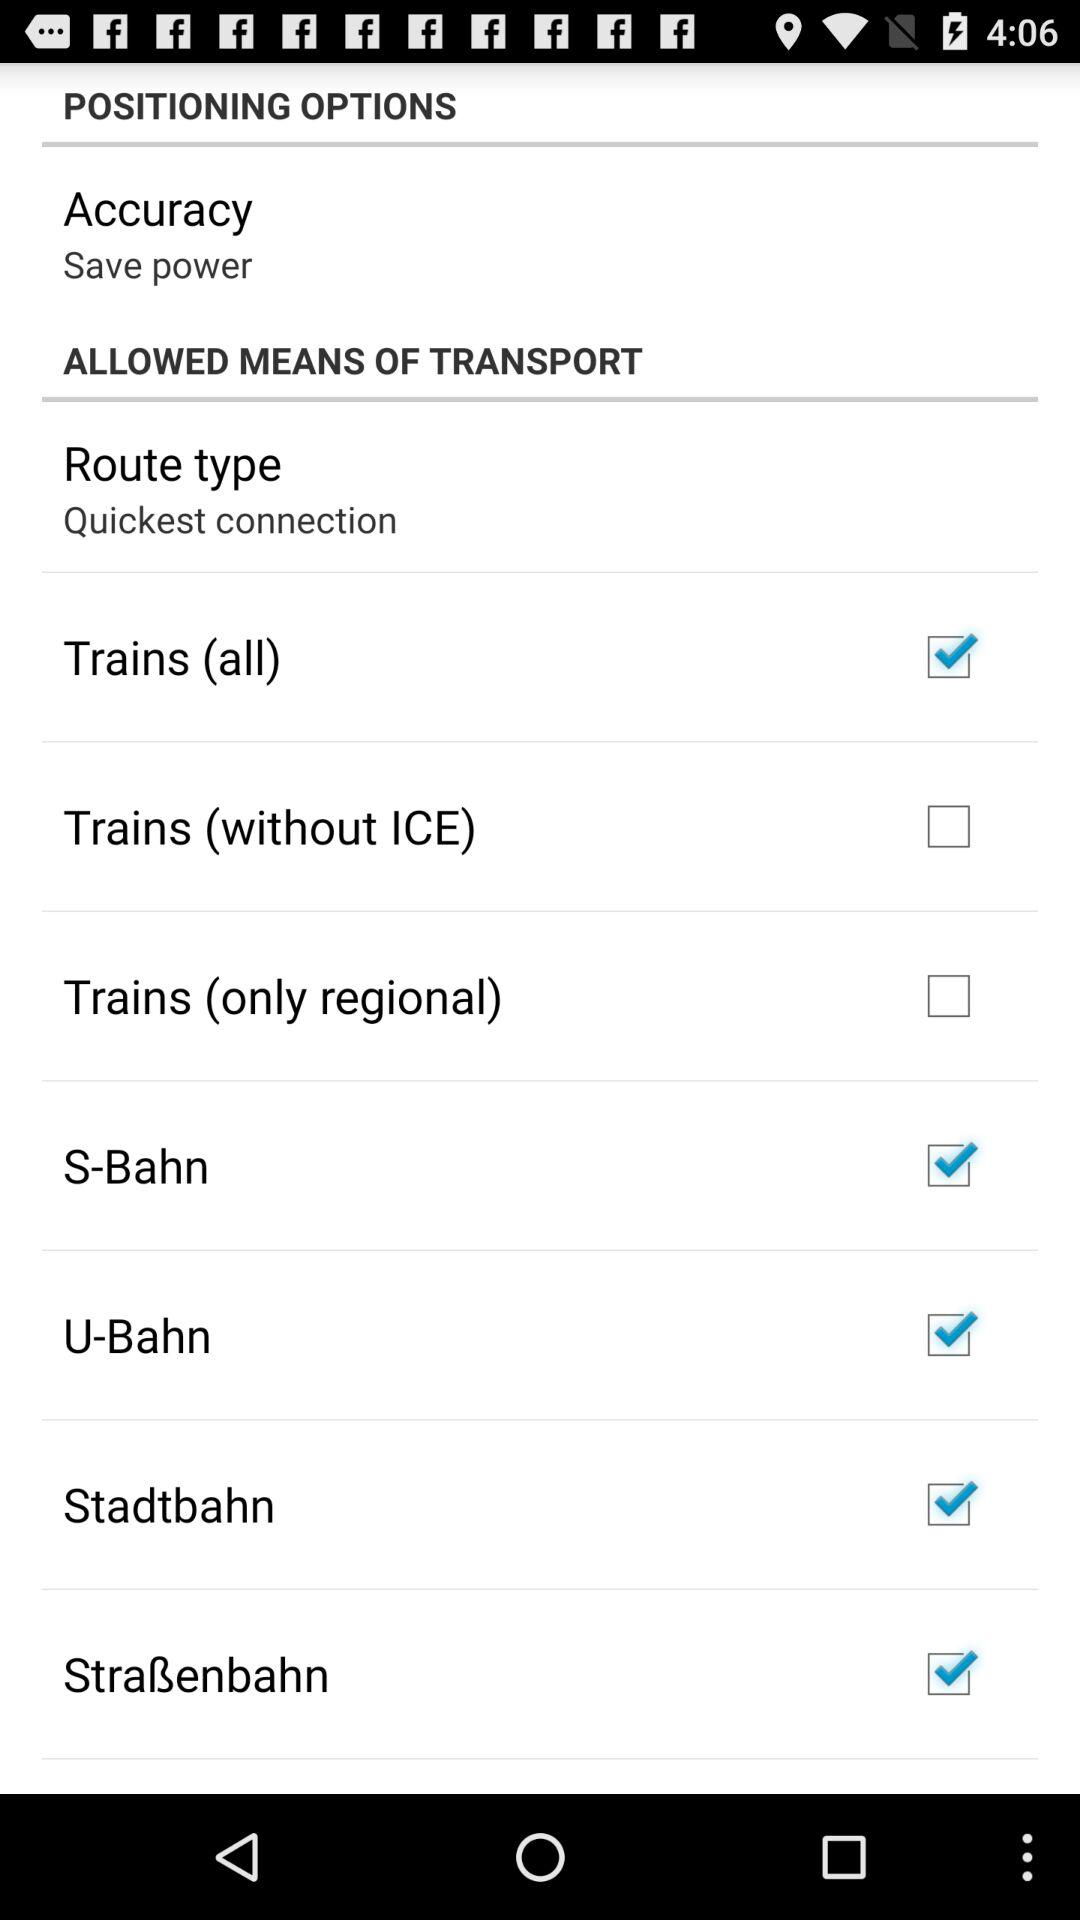Is "Trains (without ICE)" checked or unchecked?
Answer the question using a single word or phrase. It is unchecked. 